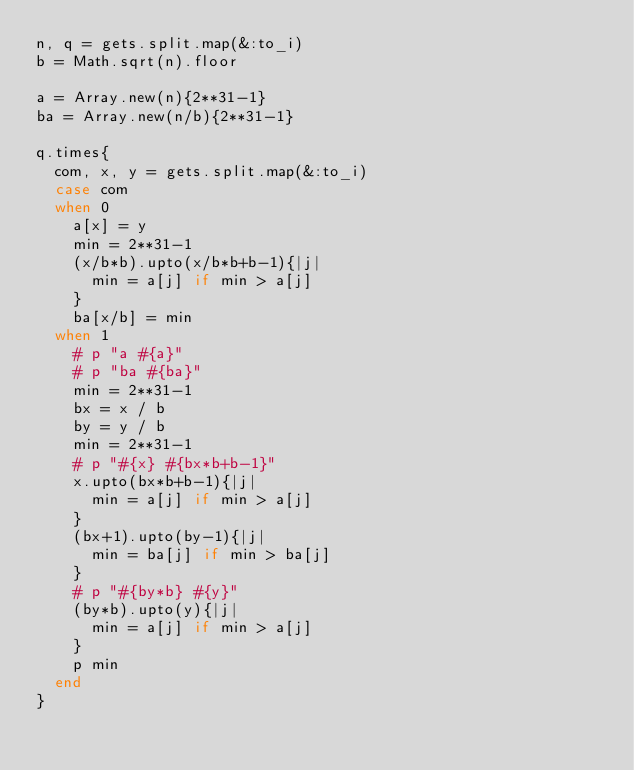Convert code to text. <code><loc_0><loc_0><loc_500><loc_500><_Ruby_>n, q = gets.split.map(&:to_i)
b = Math.sqrt(n).floor

a = Array.new(n){2**31-1}
ba = Array.new(n/b){2**31-1}

q.times{
  com, x, y = gets.split.map(&:to_i)
  case com
  when 0
    a[x] = y
    min = 2**31-1
    (x/b*b).upto(x/b*b+b-1){|j|
      min = a[j] if min > a[j]
    }
    ba[x/b] = min
  when 1
    # p "a #{a}"
    # p "ba #{ba}"
    min = 2**31-1
    bx = x / b
    by = y / b
    min = 2**31-1
    # p "#{x} #{bx*b+b-1}"
    x.upto(bx*b+b-1){|j|
      min = a[j] if min > a[j]
    }
    (bx+1).upto(by-1){|j|
      min = ba[j] if min > ba[j]
    }
    # p "#{by*b} #{y}"
    (by*b).upto(y){|j|
      min = a[j] if min > a[j]
    }
    p min
  end
}</code> 